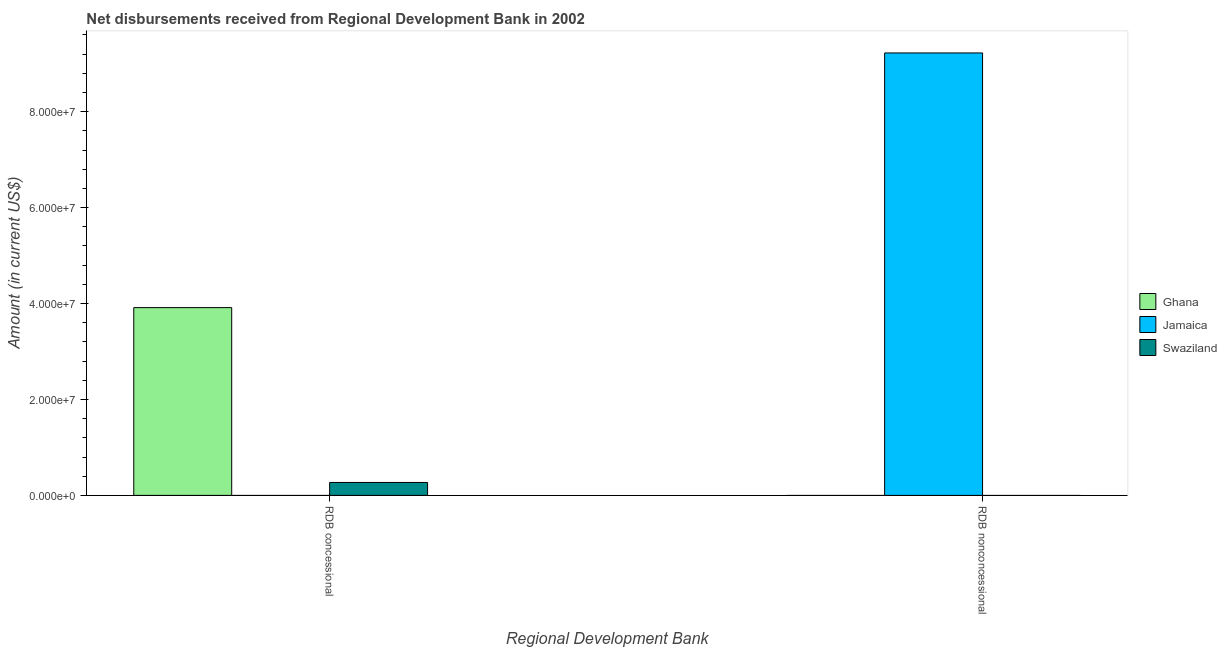How many different coloured bars are there?
Keep it short and to the point. 3. Are the number of bars on each tick of the X-axis equal?
Your response must be concise. No. How many bars are there on the 1st tick from the left?
Make the answer very short. 2. What is the label of the 2nd group of bars from the left?
Your answer should be very brief. RDB nonconcessional. What is the net non concessional disbursements from rdb in Ghana?
Offer a very short reply. 0. Across all countries, what is the maximum net non concessional disbursements from rdb?
Offer a very short reply. 9.22e+07. Across all countries, what is the minimum net concessional disbursements from rdb?
Your answer should be compact. 0. In which country was the net non concessional disbursements from rdb maximum?
Offer a terse response. Jamaica. What is the total net concessional disbursements from rdb in the graph?
Provide a short and direct response. 4.18e+07. What is the difference between the net concessional disbursements from rdb in Swaziland and that in Ghana?
Provide a short and direct response. -3.64e+07. What is the difference between the net concessional disbursements from rdb in Swaziland and the net non concessional disbursements from rdb in Ghana?
Keep it short and to the point. 2.70e+06. What is the average net concessional disbursements from rdb per country?
Ensure brevity in your answer.  1.39e+07. What is the ratio of the net concessional disbursements from rdb in Ghana to that in Swaziland?
Keep it short and to the point. 14.52. Is the net concessional disbursements from rdb in Ghana less than that in Swaziland?
Keep it short and to the point. No. How many bars are there?
Offer a very short reply. 3. Are all the bars in the graph horizontal?
Keep it short and to the point. No. How many countries are there in the graph?
Provide a short and direct response. 3. What is the difference between two consecutive major ticks on the Y-axis?
Offer a terse response. 2.00e+07. Does the graph contain any zero values?
Give a very brief answer. Yes. Does the graph contain grids?
Ensure brevity in your answer.  No. Where does the legend appear in the graph?
Offer a very short reply. Center right. How many legend labels are there?
Offer a terse response. 3. What is the title of the graph?
Your response must be concise. Net disbursements received from Regional Development Bank in 2002. Does "Nigeria" appear as one of the legend labels in the graph?
Your answer should be compact. No. What is the label or title of the X-axis?
Provide a succinct answer. Regional Development Bank. What is the Amount (in current US$) in Ghana in RDB concessional?
Your response must be concise. 3.91e+07. What is the Amount (in current US$) of Swaziland in RDB concessional?
Make the answer very short. 2.70e+06. What is the Amount (in current US$) of Ghana in RDB nonconcessional?
Your response must be concise. 0. What is the Amount (in current US$) in Jamaica in RDB nonconcessional?
Your answer should be very brief. 9.22e+07. Across all Regional Development Bank, what is the maximum Amount (in current US$) of Ghana?
Give a very brief answer. 3.91e+07. Across all Regional Development Bank, what is the maximum Amount (in current US$) in Jamaica?
Make the answer very short. 9.22e+07. Across all Regional Development Bank, what is the maximum Amount (in current US$) of Swaziland?
Your response must be concise. 2.70e+06. Across all Regional Development Bank, what is the minimum Amount (in current US$) in Ghana?
Ensure brevity in your answer.  0. What is the total Amount (in current US$) of Ghana in the graph?
Give a very brief answer. 3.91e+07. What is the total Amount (in current US$) of Jamaica in the graph?
Ensure brevity in your answer.  9.22e+07. What is the total Amount (in current US$) in Swaziland in the graph?
Offer a terse response. 2.70e+06. What is the difference between the Amount (in current US$) in Ghana in RDB concessional and the Amount (in current US$) in Jamaica in RDB nonconcessional?
Your answer should be very brief. -5.31e+07. What is the average Amount (in current US$) of Ghana per Regional Development Bank?
Give a very brief answer. 1.96e+07. What is the average Amount (in current US$) in Jamaica per Regional Development Bank?
Your answer should be very brief. 4.61e+07. What is the average Amount (in current US$) of Swaziland per Regional Development Bank?
Offer a terse response. 1.35e+06. What is the difference between the Amount (in current US$) in Ghana and Amount (in current US$) in Swaziland in RDB concessional?
Provide a short and direct response. 3.64e+07. What is the difference between the highest and the lowest Amount (in current US$) of Ghana?
Provide a short and direct response. 3.91e+07. What is the difference between the highest and the lowest Amount (in current US$) in Jamaica?
Provide a succinct answer. 9.22e+07. What is the difference between the highest and the lowest Amount (in current US$) in Swaziland?
Your response must be concise. 2.70e+06. 